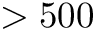<formula> <loc_0><loc_0><loc_500><loc_500>> 5 0 0</formula> 